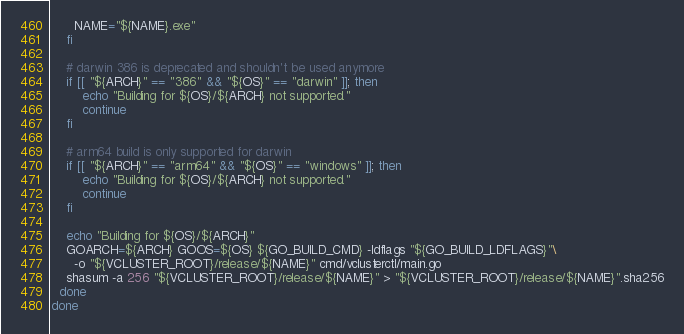Convert code to text. <code><loc_0><loc_0><loc_500><loc_500><_Bash_>      NAME="${NAME}.exe"
    fi
    
    # darwin 386 is deprecated and shouldn't be used anymore
    if [[ "${ARCH}" == "386" && "${OS}" == "darwin" ]]; then
        echo "Building for ${OS}/${ARCH} not supported."
        continue
    fi
    
    # arm64 build is only supported for darwin
    if [[ "${ARCH}" == "arm64" && "${OS}" == "windows" ]]; then
        echo "Building for ${OS}/${ARCH} not supported."
        continue
    fi

    echo "Building for ${OS}/${ARCH}"
    GOARCH=${ARCH} GOOS=${OS} ${GO_BUILD_CMD} -ldflags "${GO_BUILD_LDFLAGS}"\
      -o "${VCLUSTER_ROOT}/release/${NAME}" cmd/vclusterctl/main.go
    shasum -a 256 "${VCLUSTER_ROOT}/release/${NAME}" > "${VCLUSTER_ROOT}/release/${NAME}".sha256
  done
done
</code> 